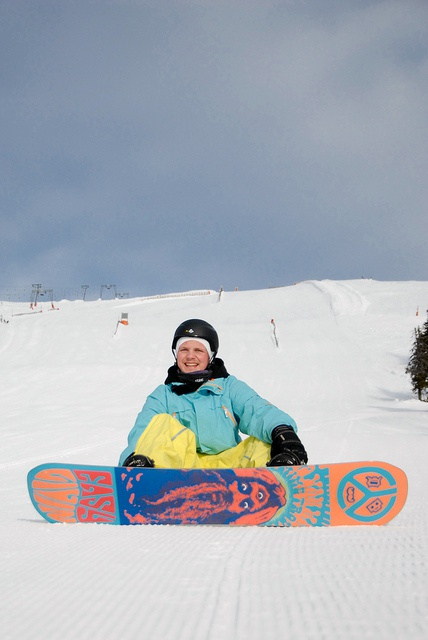Describe the objects in this image and their specific colors. I can see snowboard in gray, salmon, blue, and lightblue tones and people in gray, black, khaki, lightblue, and turquoise tones in this image. 